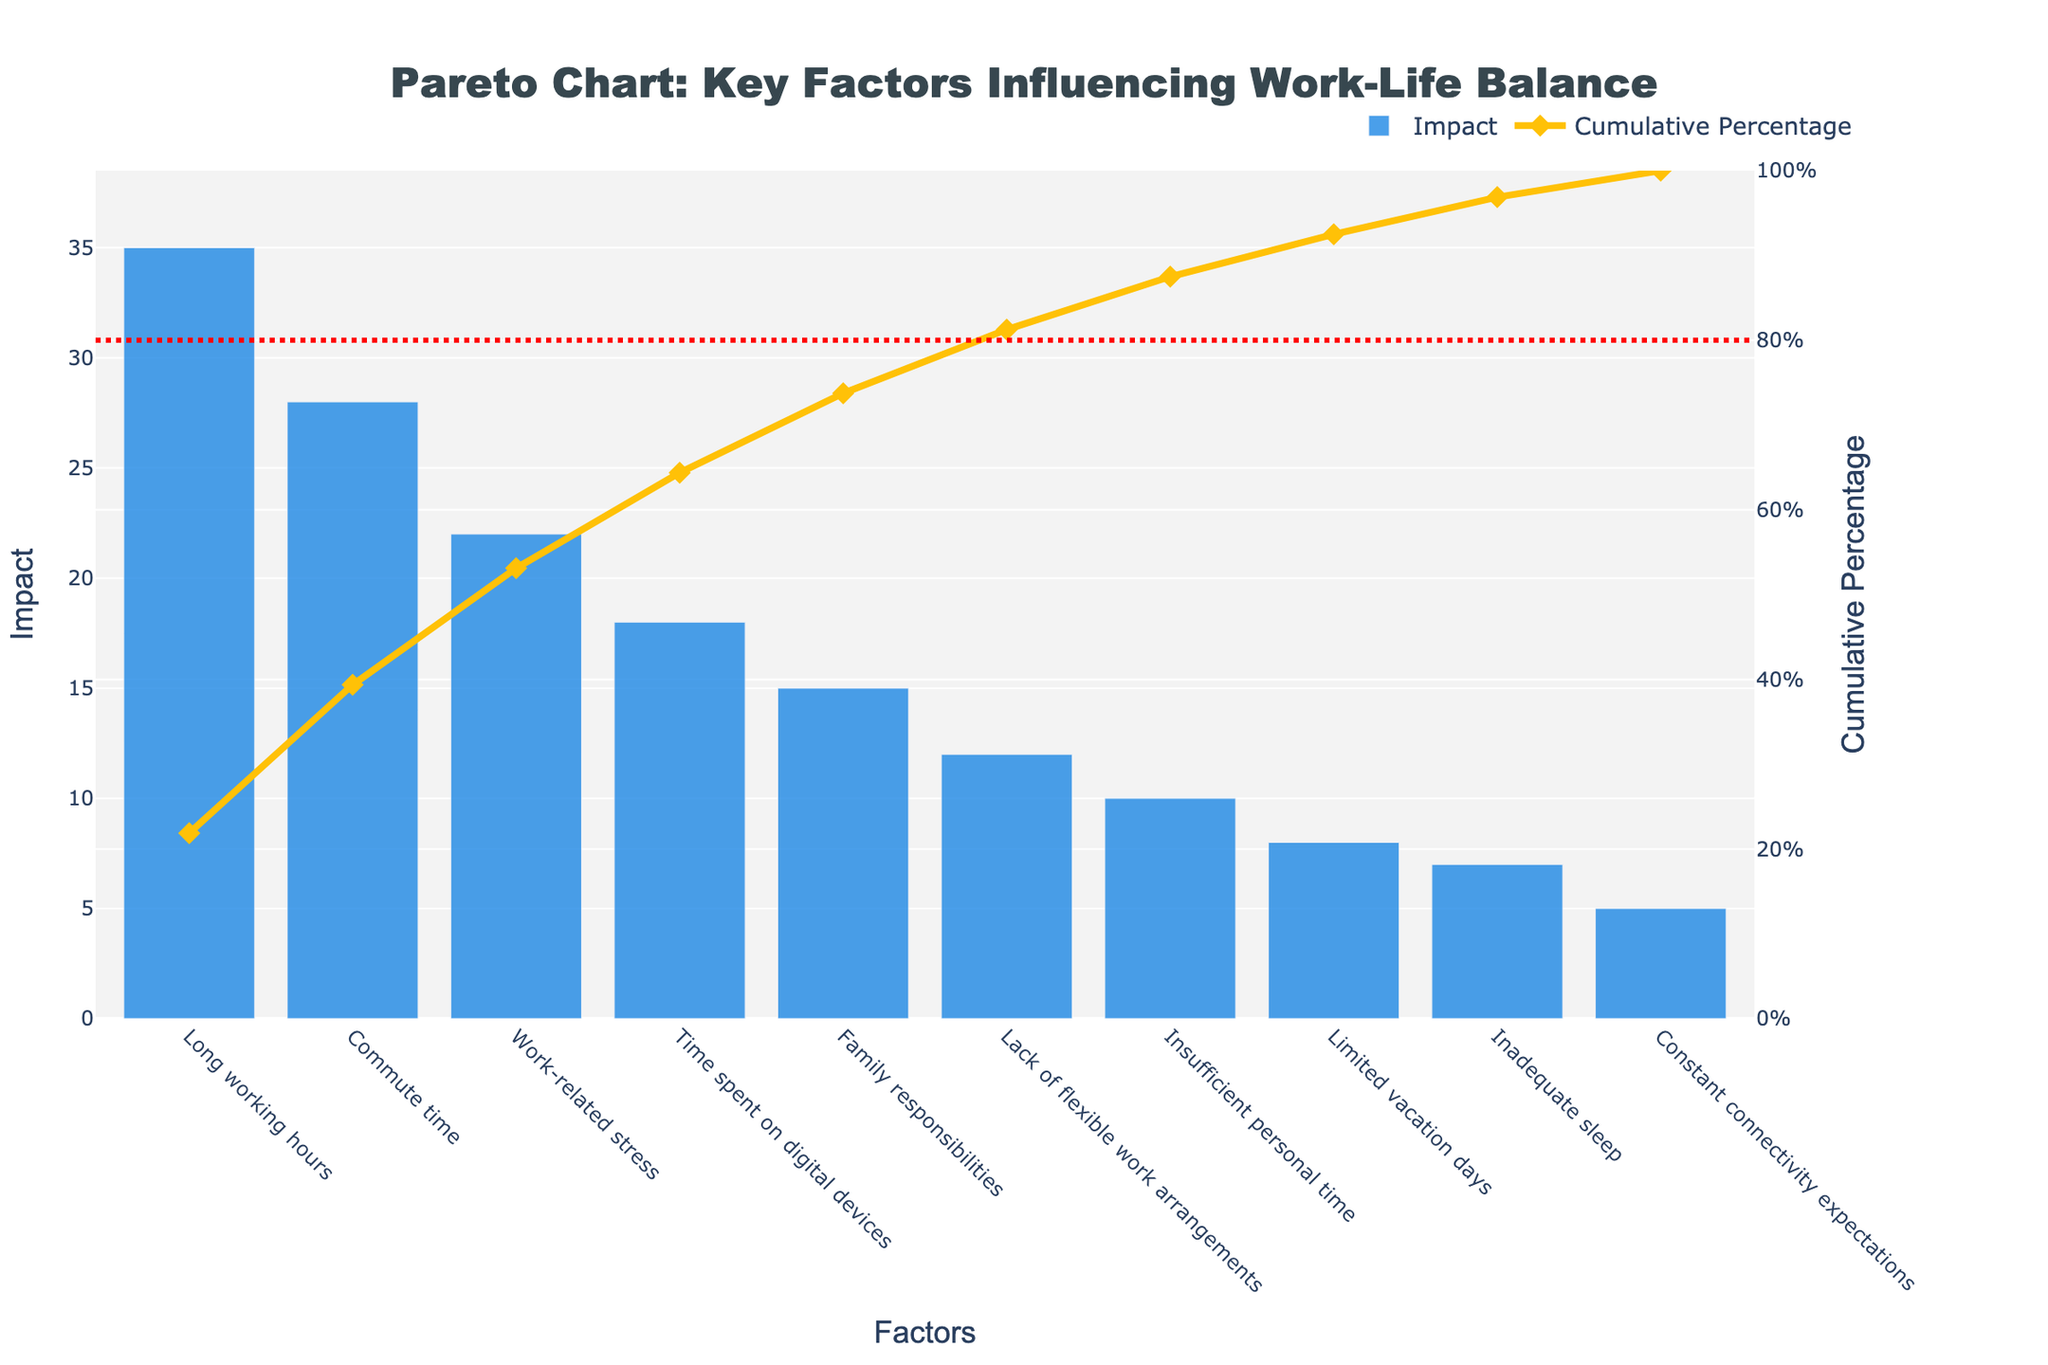What is the factor with the highest impact on work-life balance according to the chart? The factor with the highest impact is the one with the tallest bar in the chart. In this case, "Long working hours" has the tallest bar, representing an impact of 35.
Answer: Long working hours Which factor has the smallest impact on work-life balance? The factor with the smallest impact is the one with the shortest bar. "Constant connectivity expectations" has the shortest bar, representing an impact of 5.
Answer: Constant connectivity expectations What is the cumulative percentage of the impact for the top two factors? To find the cumulative percentage of the top two factors, sum their impacts and then divide by the total impact, multiplying by 100 to get a percentage. The impacts are 35 (Long working hours) and 28 (Commute time), making a total of 63. The total impact for all factors is 160. So, (63 / 160) * 100 = 39.375%.
Answer: 39.375% At what point does the cumulative percentage reach approximately 80%? To determine where the cumulative percentage reaches approximately 80%, look at the cumulative percentage line plotted on the secondary y-axis. By observing the data points in the chart, we can see that the cumulative percentage reaches around 80% between the fourth (Time spent on digital devices) and fifth factor (Family responsibilities).
Answer: Between the fourth and fifth factors How many factors account for at least 90% of the total impact on work-life balance? To find how many factors account for at least 90%, look at the cumulative percentage line. Observe the number of factors included up to where the line crosses 90%. The cumulative percentage reaches 84% after six factors (Insufficient personal time), and exceeds 90% after seven factors (Limited vacation days). So, seven factors account for at least 90%.
Answer: Seven factors Is "Family responsibilities" more impactful than "Lack of flexible work arrangements"? Compare the heights of the bars for "Family responsibilities" and "Lack of flexible work arrangements". "Family responsibilities" has an impact value of 15, while "Lack of flexible work arrangements" has an impact of 12, making "Family responsibilities" more impactful.
Answer: Yes What is the difference in impact between "Long working hours" and "Work-related stress"? Subtract the impact value of "Work-related stress" from the impact value of "Long working hours". The impact of "Long working hours" is 35, and "Work-related stress" is 22. Thus, the difference is 35 - 22 = 13.
Answer: 13 What is the impact sum of the least three impactful factors? Add the impact values of the least three impactful factors. These are "Limited vacation days" (8), "Inadequate sleep" (7), and "Constant connectivity expectations" (5). The total impact is 8 + 7 + 5 = 20.
Answer: 20 What visual elements are used to represent the impact and cumulative percentage in the chart? The chart uses bars to represent the impact of each factor and a line with markers to represent the cumulative percentage. The bars are colored blue, and the line is yellow with diamond-shaped markers.
Answer: Bars and line with markers 